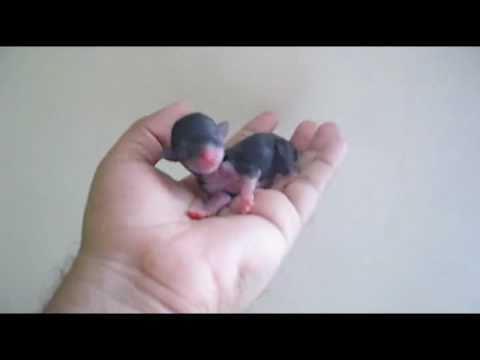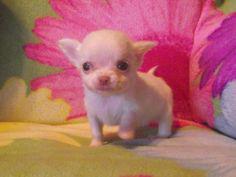The first image is the image on the left, the second image is the image on the right. For the images displayed, is the sentence "At least one image shows a tiny puppy with closed eyes, held in the palm of a hand." factually correct? Answer yes or no. Yes. The first image is the image on the left, the second image is the image on the right. Assess this claim about the two images: "Someone is holding at least one of the animals in all of the images.". Correct or not? Answer yes or no. No. 